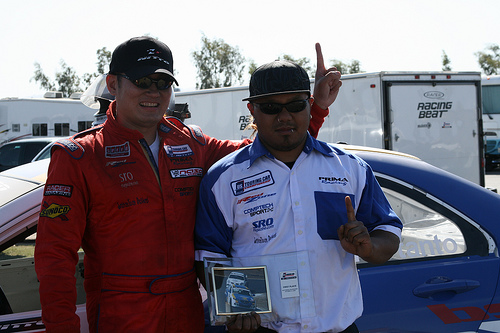<image>
Is there a glasses on the man? No. The glasses is not positioned on the man. They may be near each other, but the glasses is not supported by or resting on top of the man. 